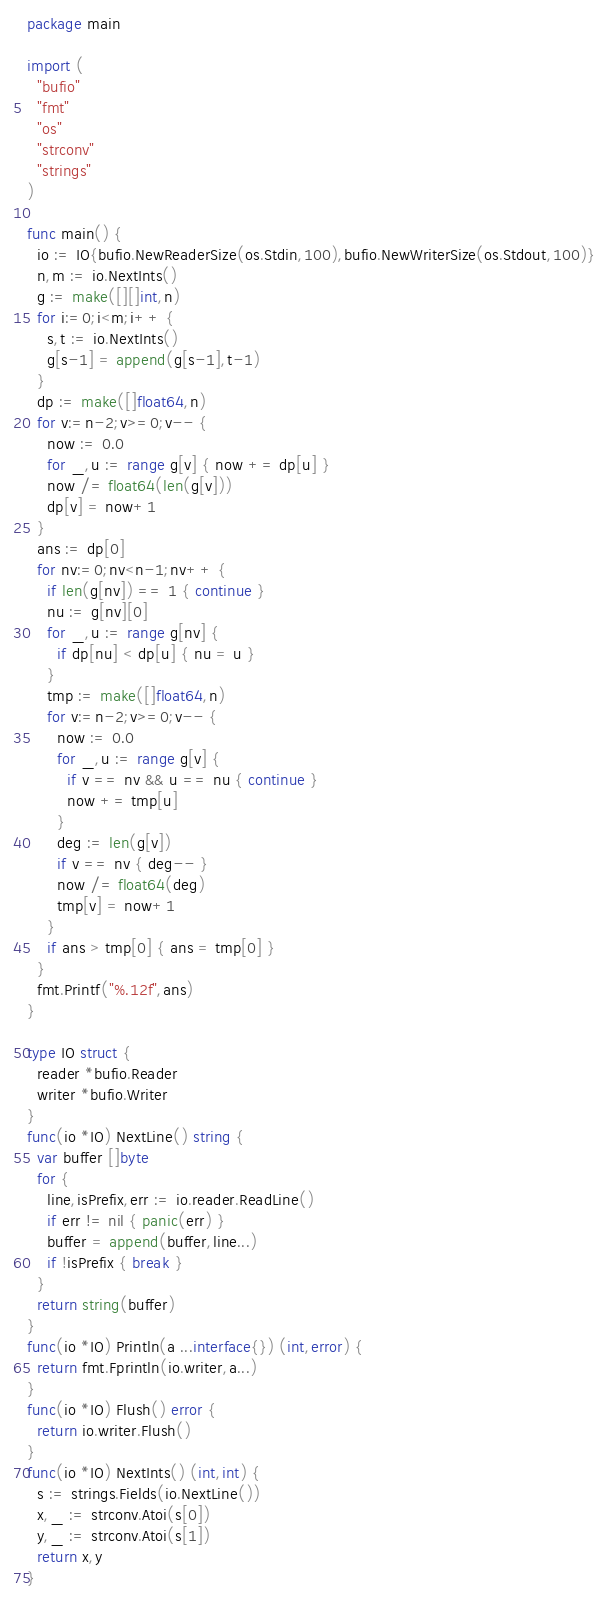Convert code to text. <code><loc_0><loc_0><loc_500><loc_500><_Go_>package main

import (
  "bufio"
  "fmt"
  "os"
  "strconv"
  "strings"
)

func main() {
  io := IO{bufio.NewReaderSize(os.Stdin,100),bufio.NewWriterSize(os.Stdout,100)}
  n,m := io.NextInts()
  g := make([][]int,n)
  for i:=0;i<m;i++ {
    s,t := io.NextInts()
    g[s-1] = append(g[s-1],t-1)
  }
  dp := make([]float64,n)
  for v:=n-2;v>=0;v-- {
    now := 0.0
    for _,u := range g[v] { now += dp[u] }
    now /= float64(len(g[v]))
    dp[v] = now+1
  }
  ans := dp[0]
  for nv:=0;nv<n-1;nv++ {
    if len(g[nv]) == 1 { continue }
    nu := g[nv][0]
    for _,u := range g[nv] {
      if dp[nu] < dp[u] { nu = u }
    }
    tmp := make([]float64,n)
    for v:=n-2;v>=0;v-- {
      now := 0.0
      for _,u := range g[v] {
        if v == nv && u == nu { continue }
        now += tmp[u]
      }
      deg := len(g[v])
      if v == nv { deg-- }
      now /= float64(deg)
      tmp[v] = now+1
    }
    if ans > tmp[0] { ans = tmp[0] }
  }
  fmt.Printf("%.12f",ans)
}

type IO struct {
  reader *bufio.Reader
  writer *bufio.Writer
}
func(io *IO) NextLine() string {
  var buffer []byte
  for {
    line,isPrefix,err := io.reader.ReadLine()
    if err != nil { panic(err) }
    buffer = append(buffer,line...)
    if !isPrefix { break }
  }
  return string(buffer)
}
func(io *IO) Println(a ...interface{}) (int,error) {
  return fmt.Fprintln(io.writer,a...)
}
func(io *IO) Flush() error {
  return io.writer.Flush()
}
func(io *IO) NextInts() (int,int) {
  s := strings.Fields(io.NextLine())
  x,_ := strconv.Atoi(s[0])
  y,_ := strconv.Atoi(s[1])
  return x,y
}</code> 